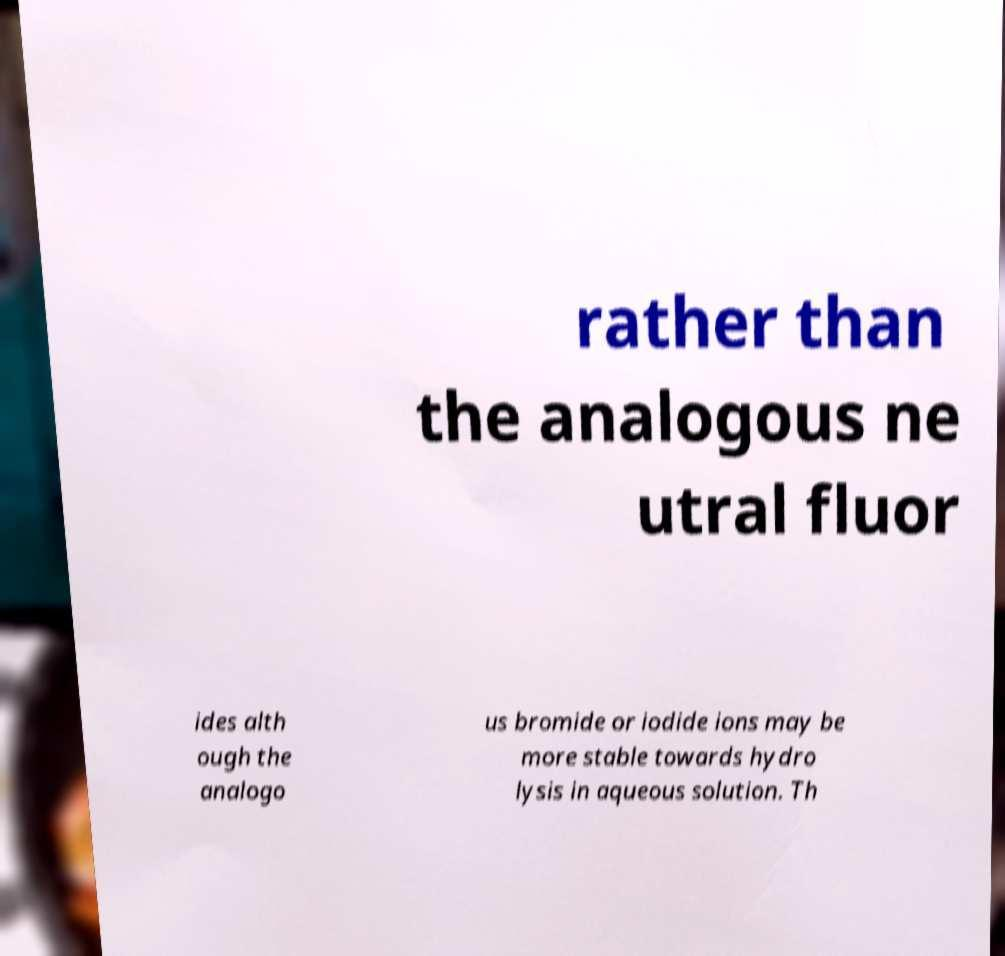For documentation purposes, I need the text within this image transcribed. Could you provide that? rather than the analogous ne utral fluor ides alth ough the analogo us bromide or iodide ions may be more stable towards hydro lysis in aqueous solution. Th 